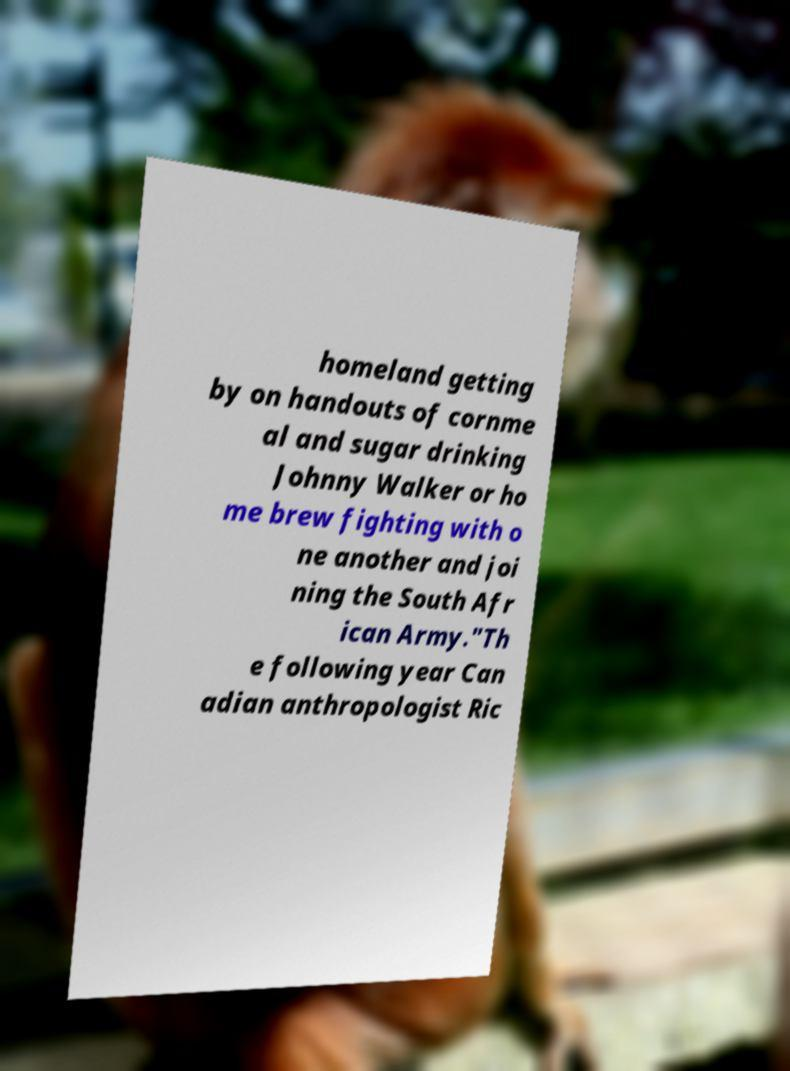Could you extract and type out the text from this image? homeland getting by on handouts of cornme al and sugar drinking Johnny Walker or ho me brew fighting with o ne another and joi ning the South Afr ican Army."Th e following year Can adian anthropologist Ric 